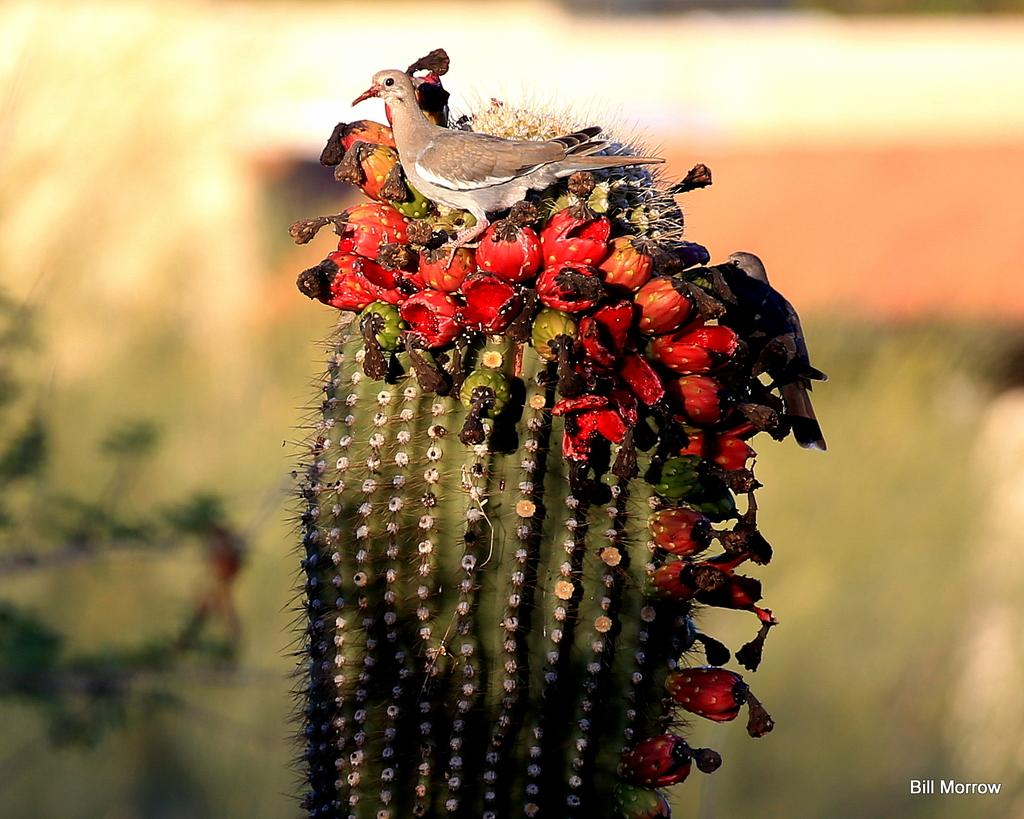What is the main subject of the image? There is a bird on a cactus plant in the image. Can you describe the background of the image? The background of the image is blurry. What else can be seen in the image besides the bird and cactus plant? There are plants visible in the image. Is there any text present in the image? Yes, there is some text at the bottom of the image. What type of blade is being used to write the text at the bottom of the image? There is no blade visible in the image, and the text appears to be printed or digitally added, not handwritten. 